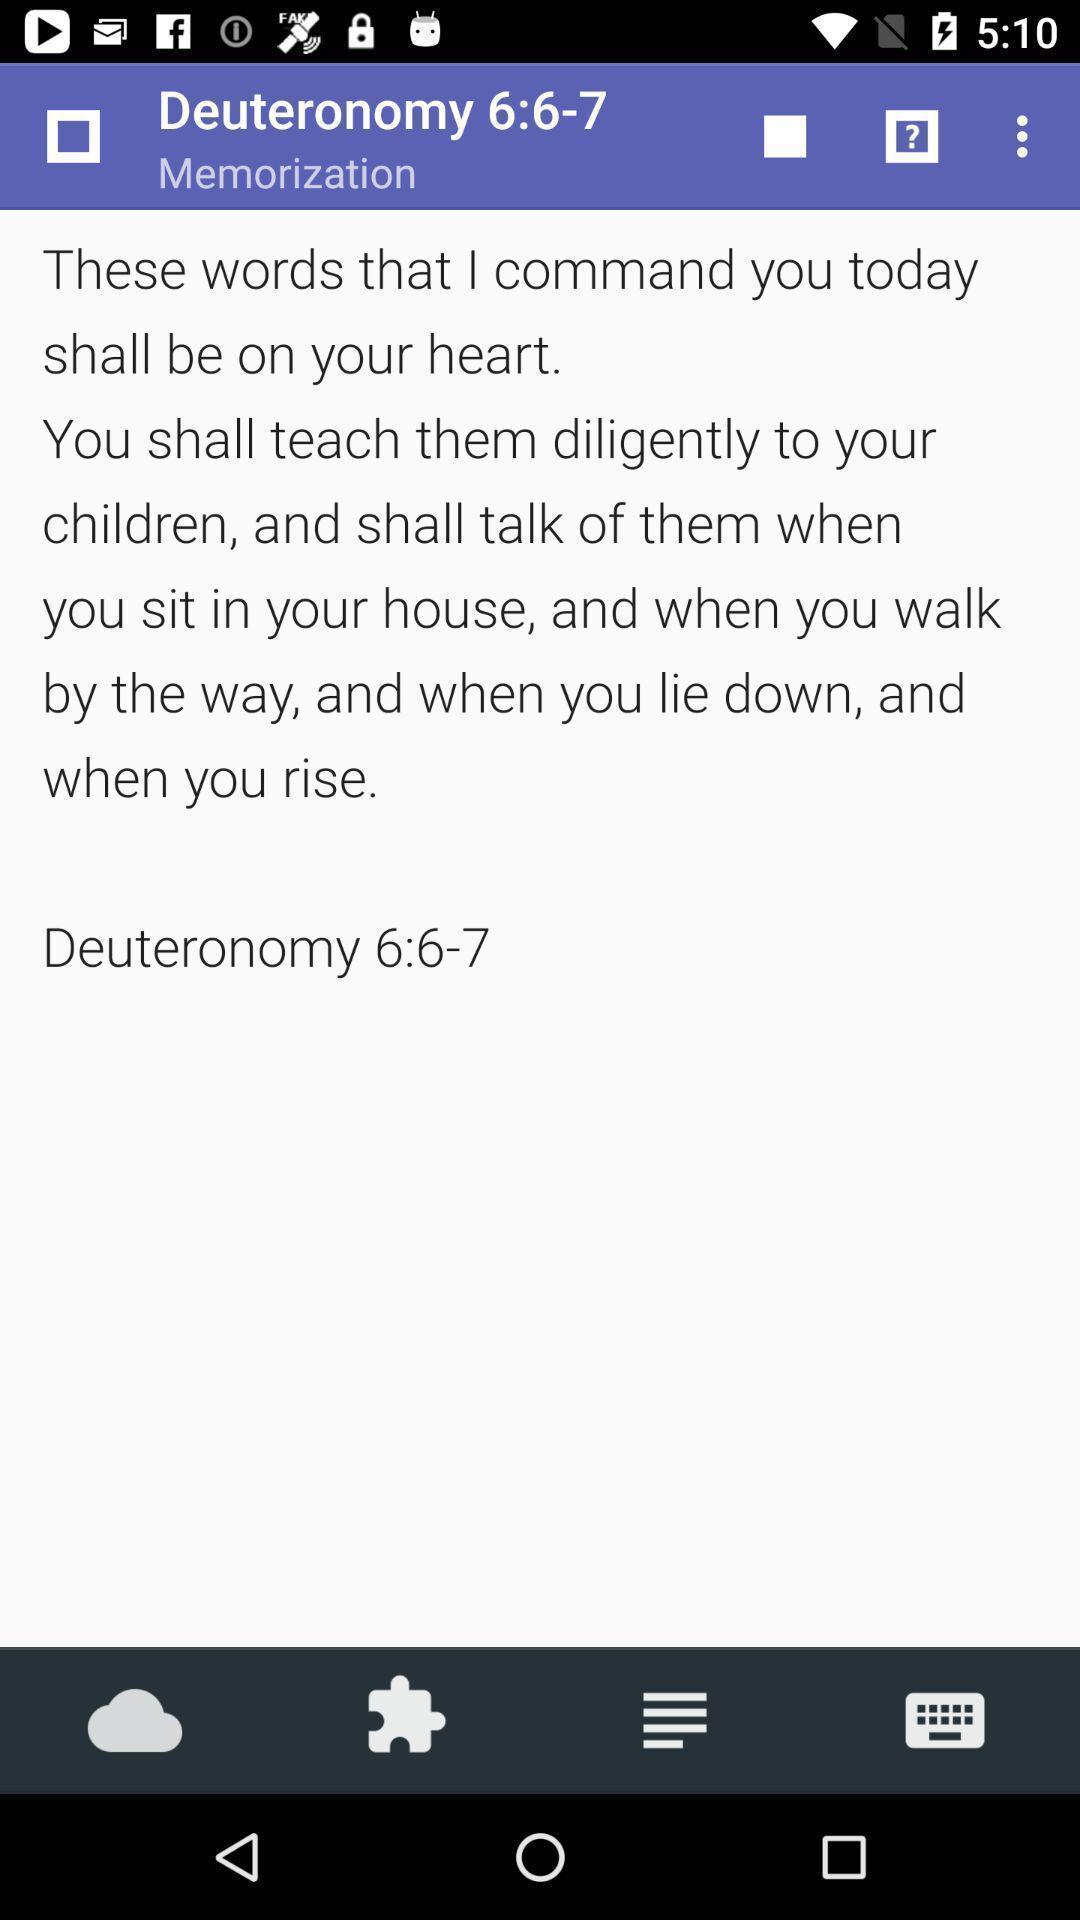Explain what's happening in this screen capture. Screen displaying page. 